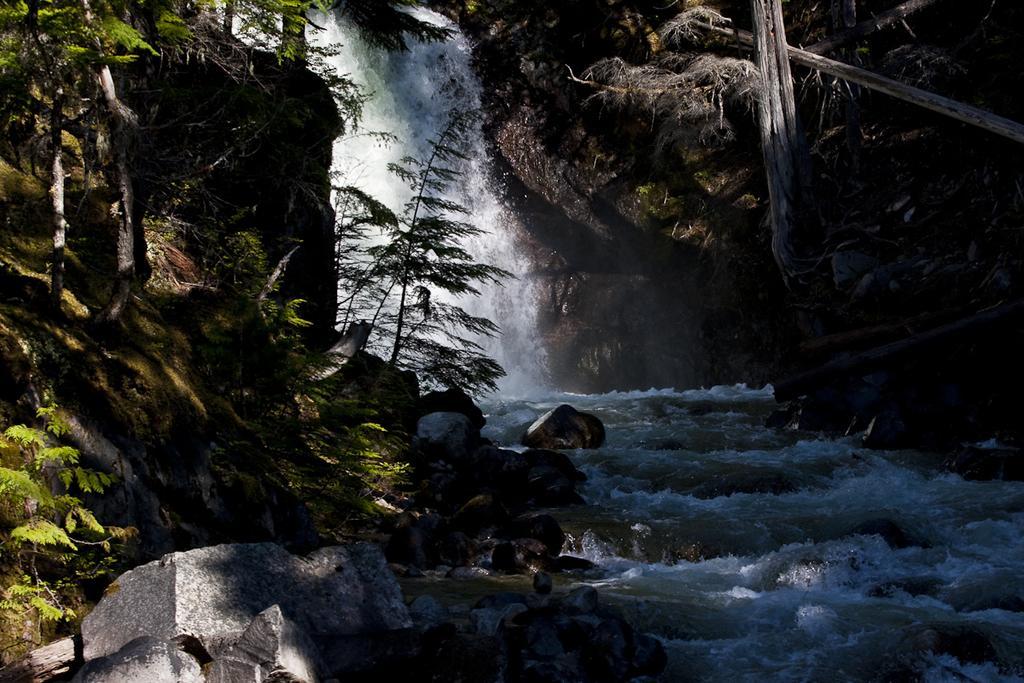How would you summarize this image in a sentence or two? In this image we can see waterfall. There are rocks. Also there are trees. 